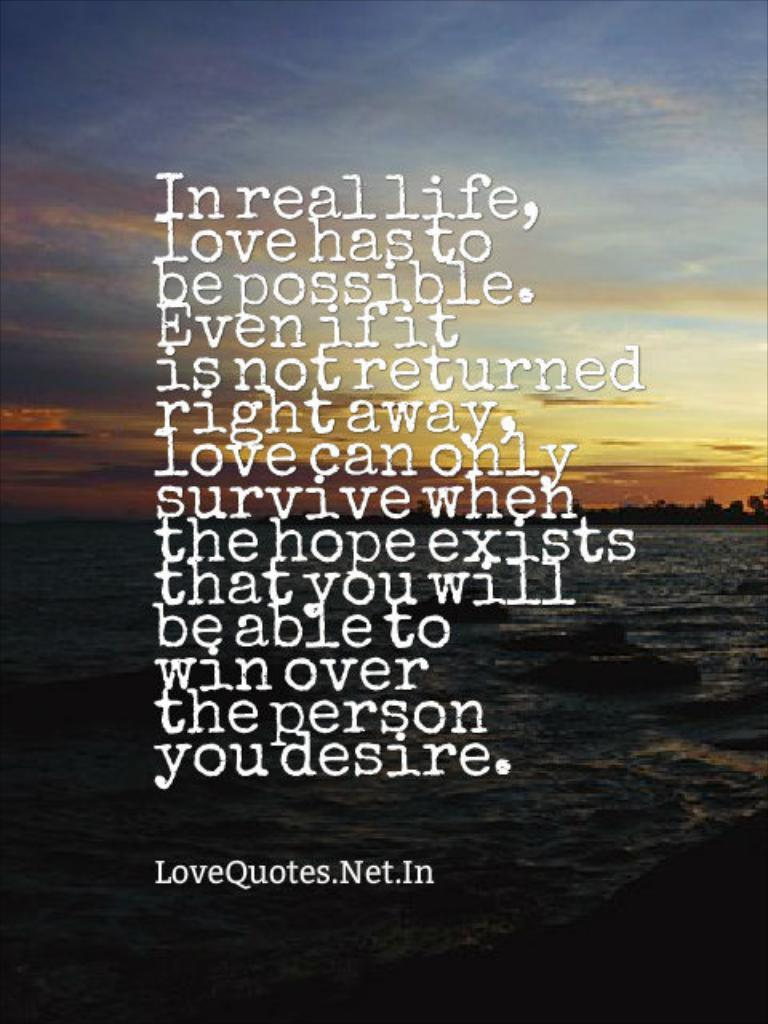<image>
Share a concise interpretation of the image provided. a quote that is from lovequotes.net and an image of a sea 